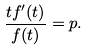Convert formula to latex. <formula><loc_0><loc_0><loc_500><loc_500>\frac { t f ^ { \prime } ( t ) } { f ( t ) } = p .</formula> 